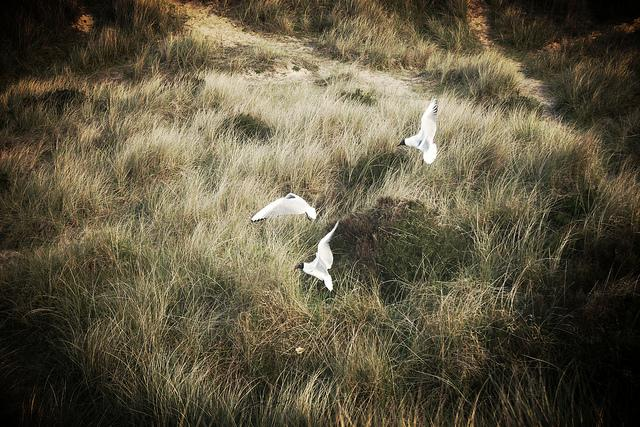What color are the beaks of these birds?

Choices:
A) green
B) yellow
C) orange
D) black black 